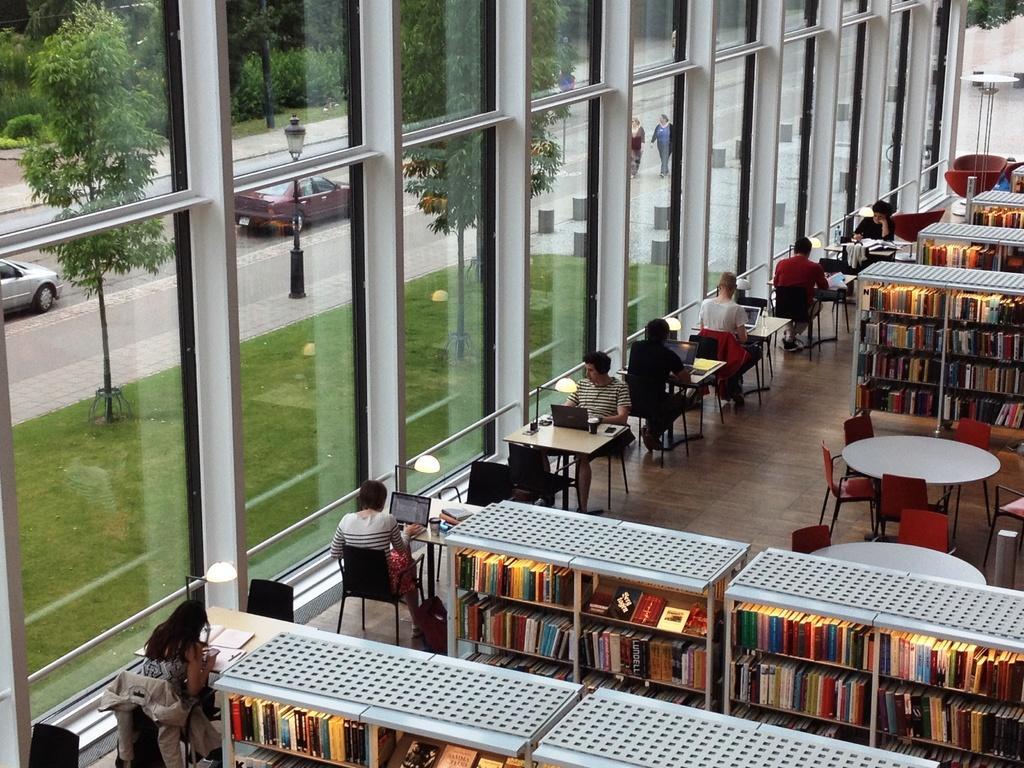How would you summarize this image in a sentence or two? In this image i can see there are few people who are sitting on a chair in front of a table. I can also see there are few cars on the road and few trees on the ground. 